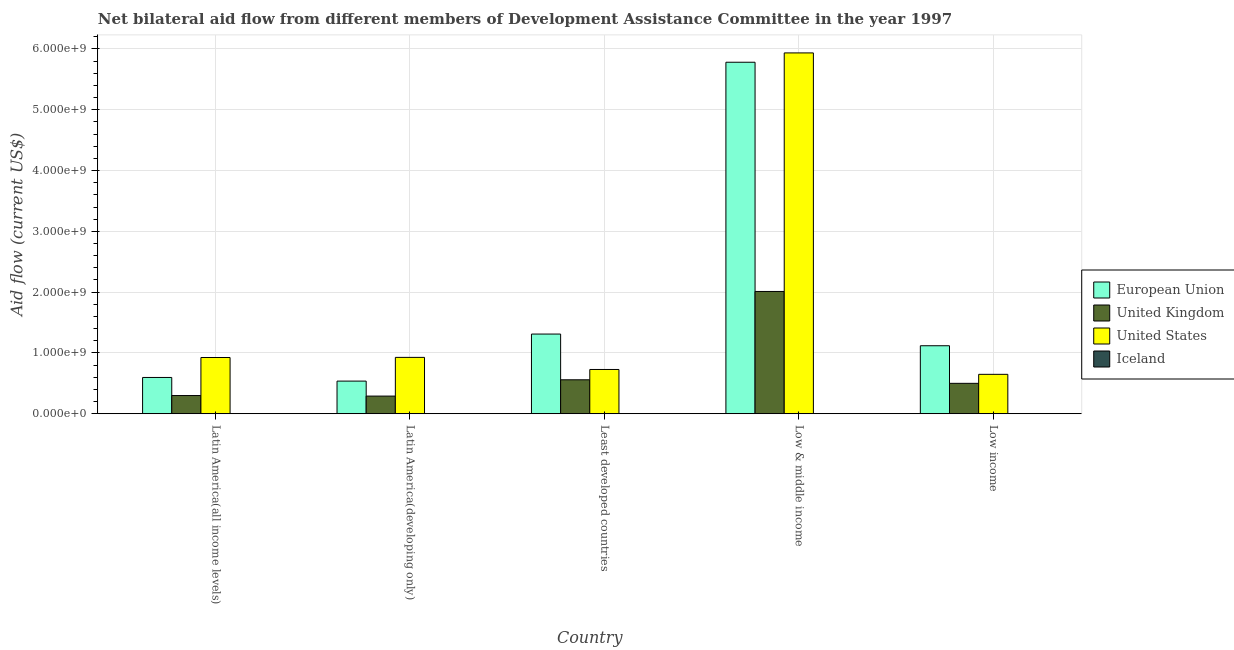How many different coloured bars are there?
Your response must be concise. 4. How many groups of bars are there?
Keep it short and to the point. 5. Are the number of bars per tick equal to the number of legend labels?
Your response must be concise. Yes. Are the number of bars on each tick of the X-axis equal?
Your response must be concise. Yes. How many bars are there on the 4th tick from the left?
Offer a very short reply. 4. What is the label of the 2nd group of bars from the left?
Keep it short and to the point. Latin America(developing only). In how many cases, is the number of bars for a given country not equal to the number of legend labels?
Your answer should be compact. 0. What is the amount of aid given by eu in Latin America(developing only)?
Ensure brevity in your answer.  5.37e+08. Across all countries, what is the maximum amount of aid given by uk?
Keep it short and to the point. 2.01e+09. Across all countries, what is the minimum amount of aid given by eu?
Ensure brevity in your answer.  5.37e+08. In which country was the amount of aid given by us maximum?
Your answer should be compact. Low & middle income. In which country was the amount of aid given by iceland minimum?
Your answer should be very brief. Low income. What is the total amount of aid given by eu in the graph?
Provide a succinct answer. 9.34e+09. What is the difference between the amount of aid given by eu in Latin America(all income levels) and that in Latin America(developing only)?
Your answer should be very brief. 5.99e+07. What is the difference between the amount of aid given by iceland in Latin America(all income levels) and the amount of aid given by eu in Least developed countries?
Give a very brief answer. -1.31e+09. What is the average amount of aid given by us per country?
Your response must be concise. 1.83e+09. What is the difference between the amount of aid given by uk and amount of aid given by eu in Latin America(all income levels)?
Offer a very short reply. -2.97e+08. What is the ratio of the amount of aid given by iceland in Least developed countries to that in Low & middle income?
Your answer should be compact. 0.47. Is the amount of aid given by uk in Latin America(all income levels) less than that in Low & middle income?
Make the answer very short. Yes. Is the difference between the amount of aid given by eu in Latin America(all income levels) and Low & middle income greater than the difference between the amount of aid given by uk in Latin America(all income levels) and Low & middle income?
Your answer should be very brief. No. What is the difference between the highest and the second highest amount of aid given by uk?
Your answer should be very brief. 1.45e+09. What is the difference between the highest and the lowest amount of aid given by iceland?
Ensure brevity in your answer.  2.70e+06. Is it the case that in every country, the sum of the amount of aid given by iceland and amount of aid given by us is greater than the sum of amount of aid given by uk and amount of aid given by eu?
Provide a short and direct response. No. What does the 4th bar from the right in Low & middle income represents?
Ensure brevity in your answer.  European Union. Is it the case that in every country, the sum of the amount of aid given by eu and amount of aid given by uk is greater than the amount of aid given by us?
Make the answer very short. No. How many bars are there?
Your answer should be compact. 20. What is the difference between two consecutive major ticks on the Y-axis?
Offer a very short reply. 1.00e+09. Does the graph contain any zero values?
Your answer should be very brief. No. Where does the legend appear in the graph?
Offer a terse response. Center right. What is the title of the graph?
Make the answer very short. Net bilateral aid flow from different members of Development Assistance Committee in the year 1997. Does "United States" appear as one of the legend labels in the graph?
Your answer should be very brief. Yes. What is the label or title of the X-axis?
Your response must be concise. Country. What is the Aid flow (current US$) in European Union in Latin America(all income levels)?
Your response must be concise. 5.97e+08. What is the Aid flow (current US$) in United Kingdom in Latin America(all income levels)?
Your answer should be compact. 2.99e+08. What is the Aid flow (current US$) of United States in Latin America(all income levels)?
Provide a short and direct response. 9.25e+08. What is the Aid flow (current US$) of Iceland in Latin America(all income levels)?
Keep it short and to the point. 2.20e+06. What is the Aid flow (current US$) in European Union in Latin America(developing only)?
Your answer should be very brief. 5.37e+08. What is the Aid flow (current US$) in United Kingdom in Latin America(developing only)?
Provide a succinct answer. 2.90e+08. What is the Aid flow (current US$) in United States in Latin America(developing only)?
Your response must be concise. 9.27e+08. What is the Aid flow (current US$) in Iceland in Latin America(developing only)?
Keep it short and to the point. 2.20e+06. What is the Aid flow (current US$) in European Union in Least developed countries?
Keep it short and to the point. 1.31e+09. What is the Aid flow (current US$) of United Kingdom in Least developed countries?
Your response must be concise. 5.58e+08. What is the Aid flow (current US$) of United States in Least developed countries?
Your answer should be very brief. 7.28e+08. What is the Aid flow (current US$) of Iceland in Least developed countries?
Your response must be concise. 1.46e+06. What is the Aid flow (current US$) of European Union in Low & middle income?
Keep it short and to the point. 5.78e+09. What is the Aid flow (current US$) in United Kingdom in Low & middle income?
Your response must be concise. 2.01e+09. What is the Aid flow (current US$) in United States in Low & middle income?
Give a very brief answer. 5.94e+09. What is the Aid flow (current US$) in Iceland in Low & middle income?
Your answer should be very brief. 3.08e+06. What is the Aid flow (current US$) in European Union in Low income?
Provide a succinct answer. 1.12e+09. What is the Aid flow (current US$) in United Kingdom in Low income?
Provide a succinct answer. 5.00e+08. What is the Aid flow (current US$) of United States in Low income?
Offer a terse response. 6.48e+08. Across all countries, what is the maximum Aid flow (current US$) of European Union?
Offer a terse response. 5.78e+09. Across all countries, what is the maximum Aid flow (current US$) of United Kingdom?
Your response must be concise. 2.01e+09. Across all countries, what is the maximum Aid flow (current US$) in United States?
Offer a terse response. 5.94e+09. Across all countries, what is the maximum Aid flow (current US$) in Iceland?
Keep it short and to the point. 3.08e+06. Across all countries, what is the minimum Aid flow (current US$) of European Union?
Your answer should be compact. 5.37e+08. Across all countries, what is the minimum Aid flow (current US$) in United Kingdom?
Your answer should be very brief. 2.90e+08. Across all countries, what is the minimum Aid flow (current US$) in United States?
Provide a succinct answer. 6.48e+08. Across all countries, what is the minimum Aid flow (current US$) of Iceland?
Provide a succinct answer. 3.80e+05. What is the total Aid flow (current US$) in European Union in the graph?
Ensure brevity in your answer.  9.34e+09. What is the total Aid flow (current US$) of United Kingdom in the graph?
Offer a terse response. 3.66e+09. What is the total Aid flow (current US$) of United States in the graph?
Keep it short and to the point. 9.16e+09. What is the total Aid flow (current US$) in Iceland in the graph?
Provide a short and direct response. 9.32e+06. What is the difference between the Aid flow (current US$) of European Union in Latin America(all income levels) and that in Latin America(developing only)?
Ensure brevity in your answer.  5.99e+07. What is the difference between the Aid flow (current US$) in United Kingdom in Latin America(all income levels) and that in Latin America(developing only)?
Provide a succinct answer. 8.87e+06. What is the difference between the Aid flow (current US$) in United States in Latin America(all income levels) and that in Latin America(developing only)?
Offer a terse response. -2.00e+06. What is the difference between the Aid flow (current US$) of Iceland in Latin America(all income levels) and that in Latin America(developing only)?
Provide a succinct answer. 0. What is the difference between the Aid flow (current US$) of European Union in Latin America(all income levels) and that in Least developed countries?
Your answer should be very brief. -7.14e+08. What is the difference between the Aid flow (current US$) of United Kingdom in Latin America(all income levels) and that in Least developed countries?
Your answer should be very brief. -2.59e+08. What is the difference between the Aid flow (current US$) of United States in Latin America(all income levels) and that in Least developed countries?
Your response must be concise. 1.97e+08. What is the difference between the Aid flow (current US$) of Iceland in Latin America(all income levels) and that in Least developed countries?
Your answer should be compact. 7.40e+05. What is the difference between the Aid flow (current US$) in European Union in Latin America(all income levels) and that in Low & middle income?
Your answer should be compact. -5.18e+09. What is the difference between the Aid flow (current US$) in United Kingdom in Latin America(all income levels) and that in Low & middle income?
Your response must be concise. -1.71e+09. What is the difference between the Aid flow (current US$) in United States in Latin America(all income levels) and that in Low & middle income?
Your response must be concise. -5.01e+09. What is the difference between the Aid flow (current US$) in Iceland in Latin America(all income levels) and that in Low & middle income?
Your response must be concise. -8.80e+05. What is the difference between the Aid flow (current US$) of European Union in Latin America(all income levels) and that in Low income?
Give a very brief answer. -5.22e+08. What is the difference between the Aid flow (current US$) in United Kingdom in Latin America(all income levels) and that in Low income?
Your answer should be compact. -2.01e+08. What is the difference between the Aid flow (current US$) in United States in Latin America(all income levels) and that in Low income?
Keep it short and to the point. 2.77e+08. What is the difference between the Aid flow (current US$) of Iceland in Latin America(all income levels) and that in Low income?
Make the answer very short. 1.82e+06. What is the difference between the Aid flow (current US$) in European Union in Latin America(developing only) and that in Least developed countries?
Make the answer very short. -7.74e+08. What is the difference between the Aid flow (current US$) of United Kingdom in Latin America(developing only) and that in Least developed countries?
Offer a very short reply. -2.68e+08. What is the difference between the Aid flow (current US$) in United States in Latin America(developing only) and that in Least developed countries?
Make the answer very short. 1.99e+08. What is the difference between the Aid flow (current US$) of Iceland in Latin America(developing only) and that in Least developed countries?
Ensure brevity in your answer.  7.40e+05. What is the difference between the Aid flow (current US$) of European Union in Latin America(developing only) and that in Low & middle income?
Keep it short and to the point. -5.24e+09. What is the difference between the Aid flow (current US$) in United Kingdom in Latin America(developing only) and that in Low & middle income?
Make the answer very short. -1.72e+09. What is the difference between the Aid flow (current US$) in United States in Latin America(developing only) and that in Low & middle income?
Your answer should be compact. -5.01e+09. What is the difference between the Aid flow (current US$) of Iceland in Latin America(developing only) and that in Low & middle income?
Offer a very short reply. -8.80e+05. What is the difference between the Aid flow (current US$) in European Union in Latin America(developing only) and that in Low income?
Make the answer very short. -5.82e+08. What is the difference between the Aid flow (current US$) in United Kingdom in Latin America(developing only) and that in Low income?
Your answer should be very brief. -2.10e+08. What is the difference between the Aid flow (current US$) of United States in Latin America(developing only) and that in Low income?
Keep it short and to the point. 2.79e+08. What is the difference between the Aid flow (current US$) of Iceland in Latin America(developing only) and that in Low income?
Your answer should be compact. 1.82e+06. What is the difference between the Aid flow (current US$) in European Union in Least developed countries and that in Low & middle income?
Provide a short and direct response. -4.47e+09. What is the difference between the Aid flow (current US$) of United Kingdom in Least developed countries and that in Low & middle income?
Your answer should be very brief. -1.45e+09. What is the difference between the Aid flow (current US$) in United States in Least developed countries and that in Low & middle income?
Provide a short and direct response. -5.21e+09. What is the difference between the Aid flow (current US$) of Iceland in Least developed countries and that in Low & middle income?
Your response must be concise. -1.62e+06. What is the difference between the Aid flow (current US$) of European Union in Least developed countries and that in Low income?
Your response must be concise. 1.92e+08. What is the difference between the Aid flow (current US$) of United Kingdom in Least developed countries and that in Low income?
Offer a terse response. 5.84e+07. What is the difference between the Aid flow (current US$) of United States in Least developed countries and that in Low income?
Offer a very short reply. 8.00e+07. What is the difference between the Aid flow (current US$) of Iceland in Least developed countries and that in Low income?
Provide a short and direct response. 1.08e+06. What is the difference between the Aid flow (current US$) in European Union in Low & middle income and that in Low income?
Provide a short and direct response. 4.66e+09. What is the difference between the Aid flow (current US$) of United Kingdom in Low & middle income and that in Low income?
Give a very brief answer. 1.51e+09. What is the difference between the Aid flow (current US$) in United States in Low & middle income and that in Low income?
Make the answer very short. 5.29e+09. What is the difference between the Aid flow (current US$) in Iceland in Low & middle income and that in Low income?
Make the answer very short. 2.70e+06. What is the difference between the Aid flow (current US$) of European Union in Latin America(all income levels) and the Aid flow (current US$) of United Kingdom in Latin America(developing only)?
Your response must be concise. 3.06e+08. What is the difference between the Aid flow (current US$) of European Union in Latin America(all income levels) and the Aid flow (current US$) of United States in Latin America(developing only)?
Your answer should be compact. -3.30e+08. What is the difference between the Aid flow (current US$) in European Union in Latin America(all income levels) and the Aid flow (current US$) in Iceland in Latin America(developing only)?
Your answer should be compact. 5.95e+08. What is the difference between the Aid flow (current US$) of United Kingdom in Latin America(all income levels) and the Aid flow (current US$) of United States in Latin America(developing only)?
Your answer should be compact. -6.28e+08. What is the difference between the Aid flow (current US$) in United Kingdom in Latin America(all income levels) and the Aid flow (current US$) in Iceland in Latin America(developing only)?
Provide a succinct answer. 2.97e+08. What is the difference between the Aid flow (current US$) of United States in Latin America(all income levels) and the Aid flow (current US$) of Iceland in Latin America(developing only)?
Provide a succinct answer. 9.23e+08. What is the difference between the Aid flow (current US$) of European Union in Latin America(all income levels) and the Aid flow (current US$) of United Kingdom in Least developed countries?
Provide a succinct answer. 3.83e+07. What is the difference between the Aid flow (current US$) of European Union in Latin America(all income levels) and the Aid flow (current US$) of United States in Least developed countries?
Offer a terse response. -1.31e+08. What is the difference between the Aid flow (current US$) in European Union in Latin America(all income levels) and the Aid flow (current US$) in Iceland in Least developed countries?
Ensure brevity in your answer.  5.95e+08. What is the difference between the Aid flow (current US$) of United Kingdom in Latin America(all income levels) and the Aid flow (current US$) of United States in Least developed countries?
Your response must be concise. -4.29e+08. What is the difference between the Aid flow (current US$) in United Kingdom in Latin America(all income levels) and the Aid flow (current US$) in Iceland in Least developed countries?
Provide a succinct answer. 2.98e+08. What is the difference between the Aid flow (current US$) in United States in Latin America(all income levels) and the Aid flow (current US$) in Iceland in Least developed countries?
Your response must be concise. 9.24e+08. What is the difference between the Aid flow (current US$) of European Union in Latin America(all income levels) and the Aid flow (current US$) of United Kingdom in Low & middle income?
Make the answer very short. -1.41e+09. What is the difference between the Aid flow (current US$) of European Union in Latin America(all income levels) and the Aid flow (current US$) of United States in Low & middle income?
Give a very brief answer. -5.34e+09. What is the difference between the Aid flow (current US$) of European Union in Latin America(all income levels) and the Aid flow (current US$) of Iceland in Low & middle income?
Keep it short and to the point. 5.94e+08. What is the difference between the Aid flow (current US$) in United Kingdom in Latin America(all income levels) and the Aid flow (current US$) in United States in Low & middle income?
Make the answer very short. -5.64e+09. What is the difference between the Aid flow (current US$) in United Kingdom in Latin America(all income levels) and the Aid flow (current US$) in Iceland in Low & middle income?
Make the answer very short. 2.96e+08. What is the difference between the Aid flow (current US$) of United States in Latin America(all income levels) and the Aid flow (current US$) of Iceland in Low & middle income?
Provide a short and direct response. 9.22e+08. What is the difference between the Aid flow (current US$) in European Union in Latin America(all income levels) and the Aid flow (current US$) in United Kingdom in Low income?
Provide a short and direct response. 9.67e+07. What is the difference between the Aid flow (current US$) in European Union in Latin America(all income levels) and the Aid flow (current US$) in United States in Low income?
Offer a terse response. -5.13e+07. What is the difference between the Aid flow (current US$) of European Union in Latin America(all income levels) and the Aid flow (current US$) of Iceland in Low income?
Give a very brief answer. 5.96e+08. What is the difference between the Aid flow (current US$) in United Kingdom in Latin America(all income levels) and the Aid flow (current US$) in United States in Low income?
Ensure brevity in your answer.  -3.49e+08. What is the difference between the Aid flow (current US$) in United Kingdom in Latin America(all income levels) and the Aid flow (current US$) in Iceland in Low income?
Make the answer very short. 2.99e+08. What is the difference between the Aid flow (current US$) of United States in Latin America(all income levels) and the Aid flow (current US$) of Iceland in Low income?
Provide a succinct answer. 9.25e+08. What is the difference between the Aid flow (current US$) of European Union in Latin America(developing only) and the Aid flow (current US$) of United Kingdom in Least developed countries?
Ensure brevity in your answer.  -2.16e+07. What is the difference between the Aid flow (current US$) of European Union in Latin America(developing only) and the Aid flow (current US$) of United States in Least developed countries?
Offer a very short reply. -1.91e+08. What is the difference between the Aid flow (current US$) of European Union in Latin America(developing only) and the Aid flow (current US$) of Iceland in Least developed countries?
Provide a succinct answer. 5.35e+08. What is the difference between the Aid flow (current US$) in United Kingdom in Latin America(developing only) and the Aid flow (current US$) in United States in Least developed countries?
Make the answer very short. -4.38e+08. What is the difference between the Aid flow (current US$) of United Kingdom in Latin America(developing only) and the Aid flow (current US$) of Iceland in Least developed countries?
Offer a very short reply. 2.89e+08. What is the difference between the Aid flow (current US$) in United States in Latin America(developing only) and the Aid flow (current US$) in Iceland in Least developed countries?
Offer a very short reply. 9.26e+08. What is the difference between the Aid flow (current US$) of European Union in Latin America(developing only) and the Aid flow (current US$) of United Kingdom in Low & middle income?
Provide a succinct answer. -1.47e+09. What is the difference between the Aid flow (current US$) of European Union in Latin America(developing only) and the Aid flow (current US$) of United States in Low & middle income?
Offer a very short reply. -5.40e+09. What is the difference between the Aid flow (current US$) in European Union in Latin America(developing only) and the Aid flow (current US$) in Iceland in Low & middle income?
Keep it short and to the point. 5.34e+08. What is the difference between the Aid flow (current US$) in United Kingdom in Latin America(developing only) and the Aid flow (current US$) in United States in Low & middle income?
Provide a succinct answer. -5.64e+09. What is the difference between the Aid flow (current US$) in United Kingdom in Latin America(developing only) and the Aid flow (current US$) in Iceland in Low & middle income?
Ensure brevity in your answer.  2.87e+08. What is the difference between the Aid flow (current US$) in United States in Latin America(developing only) and the Aid flow (current US$) in Iceland in Low & middle income?
Your answer should be very brief. 9.24e+08. What is the difference between the Aid flow (current US$) in European Union in Latin America(developing only) and the Aid flow (current US$) in United Kingdom in Low income?
Provide a short and direct response. 3.68e+07. What is the difference between the Aid flow (current US$) in European Union in Latin America(developing only) and the Aid flow (current US$) in United States in Low income?
Offer a very short reply. -1.11e+08. What is the difference between the Aid flow (current US$) of European Union in Latin America(developing only) and the Aid flow (current US$) of Iceland in Low income?
Provide a succinct answer. 5.36e+08. What is the difference between the Aid flow (current US$) of United Kingdom in Latin America(developing only) and the Aid flow (current US$) of United States in Low income?
Your answer should be very brief. -3.58e+08. What is the difference between the Aid flow (current US$) of United Kingdom in Latin America(developing only) and the Aid flow (current US$) of Iceland in Low income?
Make the answer very short. 2.90e+08. What is the difference between the Aid flow (current US$) of United States in Latin America(developing only) and the Aid flow (current US$) of Iceland in Low income?
Give a very brief answer. 9.27e+08. What is the difference between the Aid flow (current US$) in European Union in Least developed countries and the Aid flow (current US$) in United Kingdom in Low & middle income?
Make the answer very short. -7.00e+08. What is the difference between the Aid flow (current US$) of European Union in Least developed countries and the Aid flow (current US$) of United States in Low & middle income?
Offer a very short reply. -4.62e+09. What is the difference between the Aid flow (current US$) in European Union in Least developed countries and the Aid flow (current US$) in Iceland in Low & middle income?
Your answer should be very brief. 1.31e+09. What is the difference between the Aid flow (current US$) of United Kingdom in Least developed countries and the Aid flow (current US$) of United States in Low & middle income?
Provide a succinct answer. -5.38e+09. What is the difference between the Aid flow (current US$) in United Kingdom in Least developed countries and the Aid flow (current US$) in Iceland in Low & middle income?
Your response must be concise. 5.55e+08. What is the difference between the Aid flow (current US$) of United States in Least developed countries and the Aid flow (current US$) of Iceland in Low & middle income?
Keep it short and to the point. 7.25e+08. What is the difference between the Aid flow (current US$) in European Union in Least developed countries and the Aid flow (current US$) in United Kingdom in Low income?
Your answer should be compact. 8.11e+08. What is the difference between the Aid flow (current US$) in European Union in Least developed countries and the Aid flow (current US$) in United States in Low income?
Provide a succinct answer. 6.63e+08. What is the difference between the Aid flow (current US$) in European Union in Least developed countries and the Aid flow (current US$) in Iceland in Low income?
Give a very brief answer. 1.31e+09. What is the difference between the Aid flow (current US$) in United Kingdom in Least developed countries and the Aid flow (current US$) in United States in Low income?
Make the answer very short. -8.96e+07. What is the difference between the Aid flow (current US$) in United Kingdom in Least developed countries and the Aid flow (current US$) in Iceland in Low income?
Your answer should be compact. 5.58e+08. What is the difference between the Aid flow (current US$) of United States in Least developed countries and the Aid flow (current US$) of Iceland in Low income?
Your answer should be compact. 7.28e+08. What is the difference between the Aid flow (current US$) of European Union in Low & middle income and the Aid flow (current US$) of United Kingdom in Low income?
Your answer should be very brief. 5.28e+09. What is the difference between the Aid flow (current US$) of European Union in Low & middle income and the Aid flow (current US$) of United States in Low income?
Provide a short and direct response. 5.13e+09. What is the difference between the Aid flow (current US$) in European Union in Low & middle income and the Aid flow (current US$) in Iceland in Low income?
Give a very brief answer. 5.78e+09. What is the difference between the Aid flow (current US$) of United Kingdom in Low & middle income and the Aid flow (current US$) of United States in Low income?
Offer a very short reply. 1.36e+09. What is the difference between the Aid flow (current US$) in United Kingdom in Low & middle income and the Aid flow (current US$) in Iceland in Low income?
Your answer should be compact. 2.01e+09. What is the difference between the Aid flow (current US$) in United States in Low & middle income and the Aid flow (current US$) in Iceland in Low income?
Ensure brevity in your answer.  5.93e+09. What is the average Aid flow (current US$) of European Union per country?
Your answer should be compact. 1.87e+09. What is the average Aid flow (current US$) of United Kingdom per country?
Your answer should be compact. 7.32e+08. What is the average Aid flow (current US$) in United States per country?
Give a very brief answer. 1.83e+09. What is the average Aid flow (current US$) in Iceland per country?
Make the answer very short. 1.86e+06. What is the difference between the Aid flow (current US$) of European Union and Aid flow (current US$) of United Kingdom in Latin America(all income levels)?
Ensure brevity in your answer.  2.97e+08. What is the difference between the Aid flow (current US$) of European Union and Aid flow (current US$) of United States in Latin America(all income levels)?
Provide a succinct answer. -3.28e+08. What is the difference between the Aid flow (current US$) of European Union and Aid flow (current US$) of Iceland in Latin America(all income levels)?
Your answer should be compact. 5.95e+08. What is the difference between the Aid flow (current US$) of United Kingdom and Aid flow (current US$) of United States in Latin America(all income levels)?
Ensure brevity in your answer.  -6.26e+08. What is the difference between the Aid flow (current US$) of United Kingdom and Aid flow (current US$) of Iceland in Latin America(all income levels)?
Provide a short and direct response. 2.97e+08. What is the difference between the Aid flow (current US$) of United States and Aid flow (current US$) of Iceland in Latin America(all income levels)?
Provide a short and direct response. 9.23e+08. What is the difference between the Aid flow (current US$) of European Union and Aid flow (current US$) of United Kingdom in Latin America(developing only)?
Offer a very short reply. 2.46e+08. What is the difference between the Aid flow (current US$) of European Union and Aid flow (current US$) of United States in Latin America(developing only)?
Offer a very short reply. -3.90e+08. What is the difference between the Aid flow (current US$) of European Union and Aid flow (current US$) of Iceland in Latin America(developing only)?
Keep it short and to the point. 5.35e+08. What is the difference between the Aid flow (current US$) in United Kingdom and Aid flow (current US$) in United States in Latin America(developing only)?
Provide a short and direct response. -6.37e+08. What is the difference between the Aid flow (current US$) in United Kingdom and Aid flow (current US$) in Iceland in Latin America(developing only)?
Offer a terse response. 2.88e+08. What is the difference between the Aid flow (current US$) of United States and Aid flow (current US$) of Iceland in Latin America(developing only)?
Make the answer very short. 9.25e+08. What is the difference between the Aid flow (current US$) of European Union and Aid flow (current US$) of United Kingdom in Least developed countries?
Provide a short and direct response. 7.52e+08. What is the difference between the Aid flow (current US$) in European Union and Aid flow (current US$) in United States in Least developed countries?
Offer a very short reply. 5.83e+08. What is the difference between the Aid flow (current US$) of European Union and Aid flow (current US$) of Iceland in Least developed countries?
Your response must be concise. 1.31e+09. What is the difference between the Aid flow (current US$) of United Kingdom and Aid flow (current US$) of United States in Least developed countries?
Give a very brief answer. -1.70e+08. What is the difference between the Aid flow (current US$) in United Kingdom and Aid flow (current US$) in Iceland in Least developed countries?
Provide a succinct answer. 5.57e+08. What is the difference between the Aid flow (current US$) in United States and Aid flow (current US$) in Iceland in Least developed countries?
Make the answer very short. 7.27e+08. What is the difference between the Aid flow (current US$) of European Union and Aid flow (current US$) of United Kingdom in Low & middle income?
Provide a succinct answer. 3.77e+09. What is the difference between the Aid flow (current US$) in European Union and Aid flow (current US$) in United States in Low & middle income?
Your response must be concise. -1.53e+08. What is the difference between the Aid flow (current US$) in European Union and Aid flow (current US$) in Iceland in Low & middle income?
Give a very brief answer. 5.78e+09. What is the difference between the Aid flow (current US$) in United Kingdom and Aid flow (current US$) in United States in Low & middle income?
Provide a short and direct response. -3.92e+09. What is the difference between the Aid flow (current US$) of United Kingdom and Aid flow (current US$) of Iceland in Low & middle income?
Offer a terse response. 2.01e+09. What is the difference between the Aid flow (current US$) in United States and Aid flow (current US$) in Iceland in Low & middle income?
Your answer should be compact. 5.93e+09. What is the difference between the Aid flow (current US$) of European Union and Aid flow (current US$) of United Kingdom in Low income?
Offer a very short reply. 6.18e+08. What is the difference between the Aid flow (current US$) in European Union and Aid flow (current US$) in United States in Low income?
Provide a short and direct response. 4.70e+08. What is the difference between the Aid flow (current US$) of European Union and Aid flow (current US$) of Iceland in Low income?
Offer a very short reply. 1.12e+09. What is the difference between the Aid flow (current US$) in United Kingdom and Aid flow (current US$) in United States in Low income?
Make the answer very short. -1.48e+08. What is the difference between the Aid flow (current US$) of United Kingdom and Aid flow (current US$) of Iceland in Low income?
Your response must be concise. 5.00e+08. What is the difference between the Aid flow (current US$) of United States and Aid flow (current US$) of Iceland in Low income?
Give a very brief answer. 6.48e+08. What is the ratio of the Aid flow (current US$) of European Union in Latin America(all income levels) to that in Latin America(developing only)?
Your response must be concise. 1.11. What is the ratio of the Aid flow (current US$) in United Kingdom in Latin America(all income levels) to that in Latin America(developing only)?
Make the answer very short. 1.03. What is the ratio of the Aid flow (current US$) in European Union in Latin America(all income levels) to that in Least developed countries?
Your response must be concise. 0.46. What is the ratio of the Aid flow (current US$) of United Kingdom in Latin America(all income levels) to that in Least developed countries?
Your response must be concise. 0.54. What is the ratio of the Aid flow (current US$) of United States in Latin America(all income levels) to that in Least developed countries?
Ensure brevity in your answer.  1.27. What is the ratio of the Aid flow (current US$) in Iceland in Latin America(all income levels) to that in Least developed countries?
Ensure brevity in your answer.  1.51. What is the ratio of the Aid flow (current US$) of European Union in Latin America(all income levels) to that in Low & middle income?
Your response must be concise. 0.1. What is the ratio of the Aid flow (current US$) of United Kingdom in Latin America(all income levels) to that in Low & middle income?
Offer a very short reply. 0.15. What is the ratio of the Aid flow (current US$) in United States in Latin America(all income levels) to that in Low & middle income?
Ensure brevity in your answer.  0.16. What is the ratio of the Aid flow (current US$) in European Union in Latin America(all income levels) to that in Low income?
Provide a succinct answer. 0.53. What is the ratio of the Aid flow (current US$) in United Kingdom in Latin America(all income levels) to that in Low income?
Ensure brevity in your answer.  0.6. What is the ratio of the Aid flow (current US$) in United States in Latin America(all income levels) to that in Low income?
Give a very brief answer. 1.43. What is the ratio of the Aid flow (current US$) of Iceland in Latin America(all income levels) to that in Low income?
Give a very brief answer. 5.79. What is the ratio of the Aid flow (current US$) in European Union in Latin America(developing only) to that in Least developed countries?
Ensure brevity in your answer.  0.41. What is the ratio of the Aid flow (current US$) in United Kingdom in Latin America(developing only) to that in Least developed countries?
Offer a very short reply. 0.52. What is the ratio of the Aid flow (current US$) in United States in Latin America(developing only) to that in Least developed countries?
Your answer should be compact. 1.27. What is the ratio of the Aid flow (current US$) in Iceland in Latin America(developing only) to that in Least developed countries?
Offer a very short reply. 1.51. What is the ratio of the Aid flow (current US$) of European Union in Latin America(developing only) to that in Low & middle income?
Make the answer very short. 0.09. What is the ratio of the Aid flow (current US$) in United Kingdom in Latin America(developing only) to that in Low & middle income?
Make the answer very short. 0.14. What is the ratio of the Aid flow (current US$) of United States in Latin America(developing only) to that in Low & middle income?
Your answer should be compact. 0.16. What is the ratio of the Aid flow (current US$) in Iceland in Latin America(developing only) to that in Low & middle income?
Your response must be concise. 0.71. What is the ratio of the Aid flow (current US$) in European Union in Latin America(developing only) to that in Low income?
Ensure brevity in your answer.  0.48. What is the ratio of the Aid flow (current US$) of United Kingdom in Latin America(developing only) to that in Low income?
Offer a very short reply. 0.58. What is the ratio of the Aid flow (current US$) of United States in Latin America(developing only) to that in Low income?
Make the answer very short. 1.43. What is the ratio of the Aid flow (current US$) in Iceland in Latin America(developing only) to that in Low income?
Make the answer very short. 5.79. What is the ratio of the Aid flow (current US$) of European Union in Least developed countries to that in Low & middle income?
Your answer should be very brief. 0.23. What is the ratio of the Aid flow (current US$) of United Kingdom in Least developed countries to that in Low & middle income?
Ensure brevity in your answer.  0.28. What is the ratio of the Aid flow (current US$) in United States in Least developed countries to that in Low & middle income?
Your answer should be very brief. 0.12. What is the ratio of the Aid flow (current US$) in Iceland in Least developed countries to that in Low & middle income?
Your response must be concise. 0.47. What is the ratio of the Aid flow (current US$) of European Union in Least developed countries to that in Low income?
Offer a terse response. 1.17. What is the ratio of the Aid flow (current US$) in United Kingdom in Least developed countries to that in Low income?
Provide a short and direct response. 1.12. What is the ratio of the Aid flow (current US$) in United States in Least developed countries to that in Low income?
Offer a terse response. 1.12. What is the ratio of the Aid flow (current US$) in Iceland in Least developed countries to that in Low income?
Keep it short and to the point. 3.84. What is the ratio of the Aid flow (current US$) in European Union in Low & middle income to that in Low income?
Offer a very short reply. 5.17. What is the ratio of the Aid flow (current US$) of United Kingdom in Low & middle income to that in Low income?
Your response must be concise. 4.02. What is the ratio of the Aid flow (current US$) in United States in Low & middle income to that in Low income?
Ensure brevity in your answer.  9.16. What is the ratio of the Aid flow (current US$) in Iceland in Low & middle income to that in Low income?
Offer a very short reply. 8.11. What is the difference between the highest and the second highest Aid flow (current US$) of European Union?
Your answer should be compact. 4.47e+09. What is the difference between the highest and the second highest Aid flow (current US$) of United Kingdom?
Keep it short and to the point. 1.45e+09. What is the difference between the highest and the second highest Aid flow (current US$) in United States?
Provide a short and direct response. 5.01e+09. What is the difference between the highest and the second highest Aid flow (current US$) in Iceland?
Your response must be concise. 8.80e+05. What is the difference between the highest and the lowest Aid flow (current US$) in European Union?
Keep it short and to the point. 5.24e+09. What is the difference between the highest and the lowest Aid flow (current US$) of United Kingdom?
Your answer should be compact. 1.72e+09. What is the difference between the highest and the lowest Aid flow (current US$) of United States?
Your answer should be very brief. 5.29e+09. What is the difference between the highest and the lowest Aid flow (current US$) in Iceland?
Keep it short and to the point. 2.70e+06. 